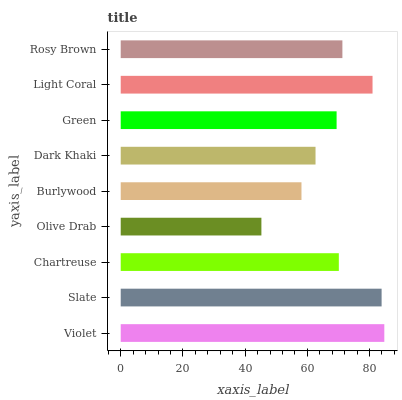Is Olive Drab the minimum?
Answer yes or no. Yes. Is Violet the maximum?
Answer yes or no. Yes. Is Slate the minimum?
Answer yes or no. No. Is Slate the maximum?
Answer yes or no. No. Is Violet greater than Slate?
Answer yes or no. Yes. Is Slate less than Violet?
Answer yes or no. Yes. Is Slate greater than Violet?
Answer yes or no. No. Is Violet less than Slate?
Answer yes or no. No. Is Chartreuse the high median?
Answer yes or no. Yes. Is Chartreuse the low median?
Answer yes or no. Yes. Is Violet the high median?
Answer yes or no. No. Is Light Coral the low median?
Answer yes or no. No. 